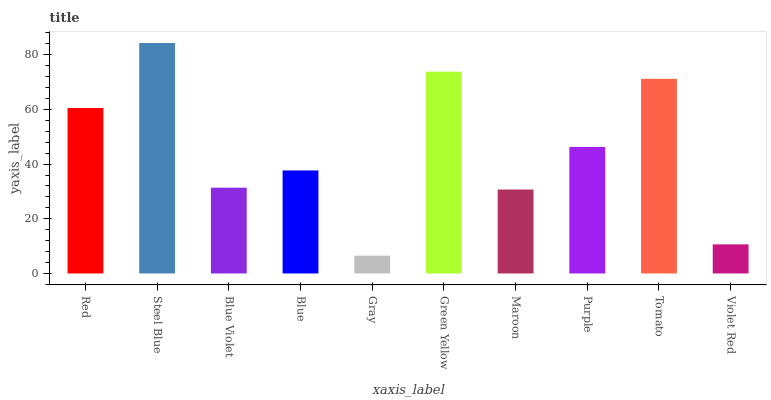Is Gray the minimum?
Answer yes or no. Yes. Is Steel Blue the maximum?
Answer yes or no. Yes. Is Blue Violet the minimum?
Answer yes or no. No. Is Blue Violet the maximum?
Answer yes or no. No. Is Steel Blue greater than Blue Violet?
Answer yes or no. Yes. Is Blue Violet less than Steel Blue?
Answer yes or no. Yes. Is Blue Violet greater than Steel Blue?
Answer yes or no. No. Is Steel Blue less than Blue Violet?
Answer yes or no. No. Is Purple the high median?
Answer yes or no. Yes. Is Blue the low median?
Answer yes or no. Yes. Is Blue the high median?
Answer yes or no. No. Is Green Yellow the low median?
Answer yes or no. No. 